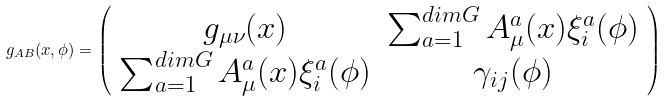Convert formula to latex. <formula><loc_0><loc_0><loc_500><loc_500>g _ { A B } ( x , \phi ) = \left ( \begin{array} { c c } g _ { \mu \nu } ( x ) & \sum _ { a = 1 } ^ { d i m G } A _ { \mu } ^ { a } ( x ) \xi _ { i } ^ { a } ( \phi ) \\ \sum _ { a = 1 } ^ { d i m G } A _ { \mu } ^ { a } ( x ) \xi _ { i } ^ { a } ( \phi ) & \gamma _ { i j } ( \phi ) \end{array} \right )</formula> 